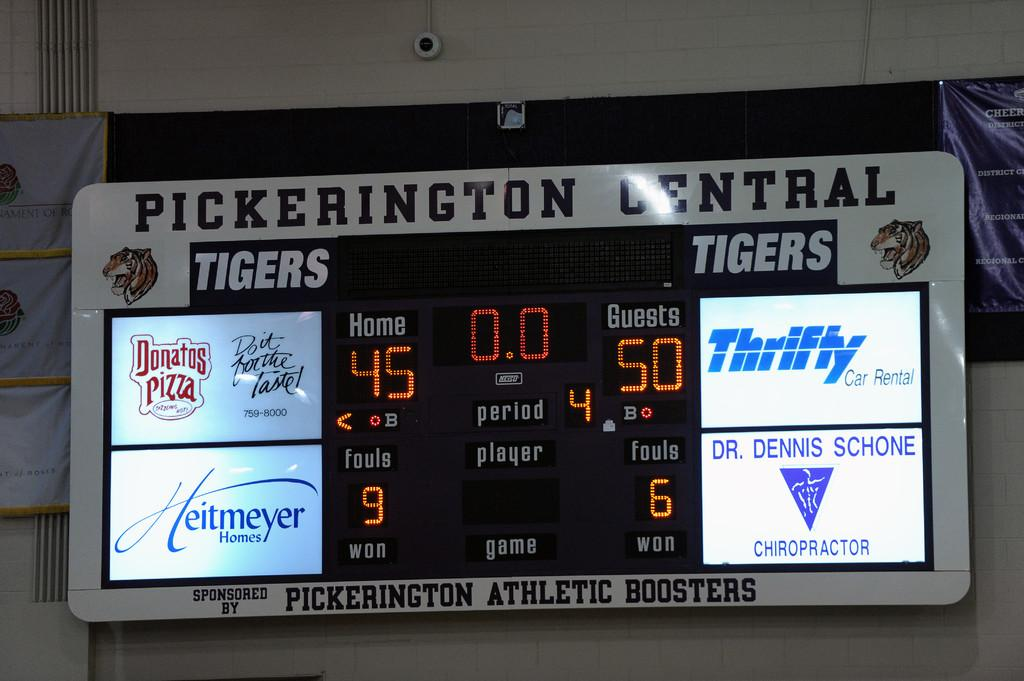<image>
Share a concise interpretation of the image provided. A scoreboard from Pickerington Central with four digital advertisements. 